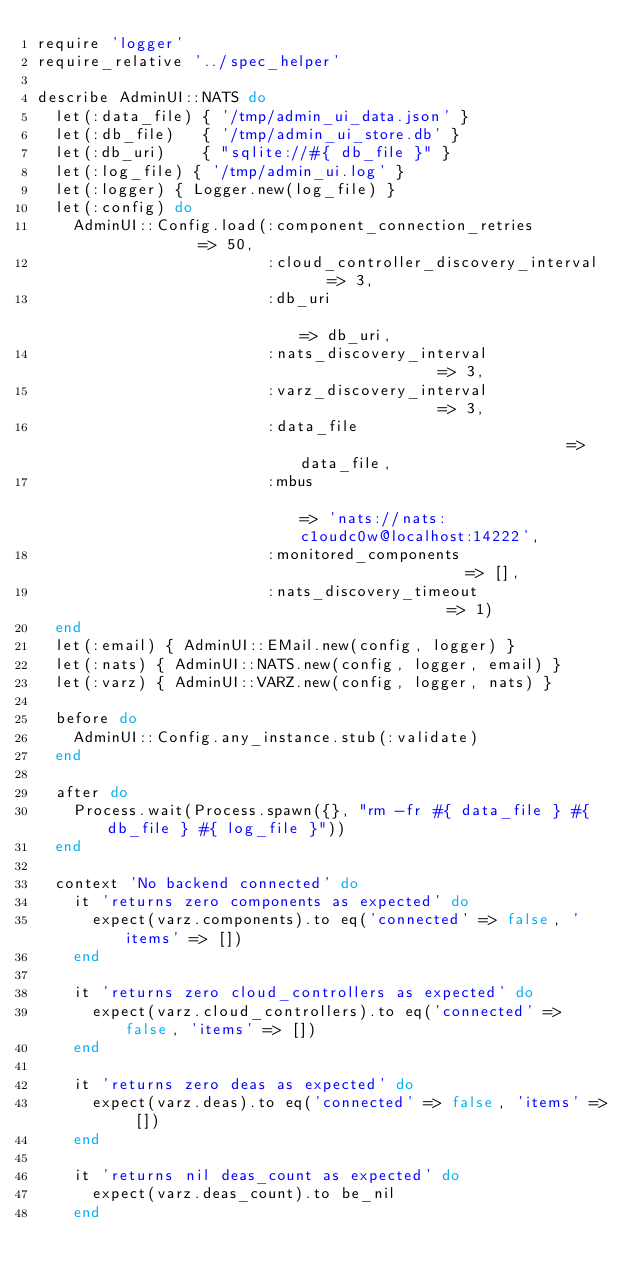<code> <loc_0><loc_0><loc_500><loc_500><_Ruby_>require 'logger'
require_relative '../spec_helper'

describe AdminUI::NATS do
  let(:data_file) { '/tmp/admin_ui_data.json' }
  let(:db_file)   { '/tmp/admin_ui_store.db' }
  let(:db_uri)    { "sqlite://#{ db_file }" }
  let(:log_file) { '/tmp/admin_ui.log' }
  let(:logger) { Logger.new(log_file) }
  let(:config) do
    AdminUI::Config.load(:component_connection_retries           => 50,
                         :cloud_controller_discovery_interval    => 3,
                         :db_uri                                 => db_uri,
                         :nats_discovery_interval                => 3,
                         :varz_discovery_interval                => 3,
                         :data_file                              => data_file,
                         :mbus                                   => 'nats://nats:c1oudc0w@localhost:14222',
                         :monitored_components                   => [],
                         :nats_discovery_timeout                 => 1)
  end
  let(:email) { AdminUI::EMail.new(config, logger) }
  let(:nats) { AdminUI::NATS.new(config, logger, email) }
  let(:varz) { AdminUI::VARZ.new(config, logger, nats) }

  before do
    AdminUI::Config.any_instance.stub(:validate)
  end

  after do
    Process.wait(Process.spawn({}, "rm -fr #{ data_file } #{ db_file } #{ log_file }"))
  end

  context 'No backend connected' do
    it 'returns zero components as expected' do
      expect(varz.components).to eq('connected' => false, 'items' => [])
    end

    it 'returns zero cloud_controllers as expected' do
      expect(varz.cloud_controllers).to eq('connected' => false, 'items' => [])
    end

    it 'returns zero deas as expected' do
      expect(varz.deas).to eq('connected' => false, 'items' => [])
    end

    it 'returns nil deas_count as expected' do
      expect(varz.deas_count).to be_nil
    end
</code> 